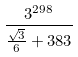<formula> <loc_0><loc_0><loc_500><loc_500>\frac { 3 ^ { 2 9 8 } } { \frac { \sqrt { 3 } } { 6 } + 3 8 3 }</formula> 